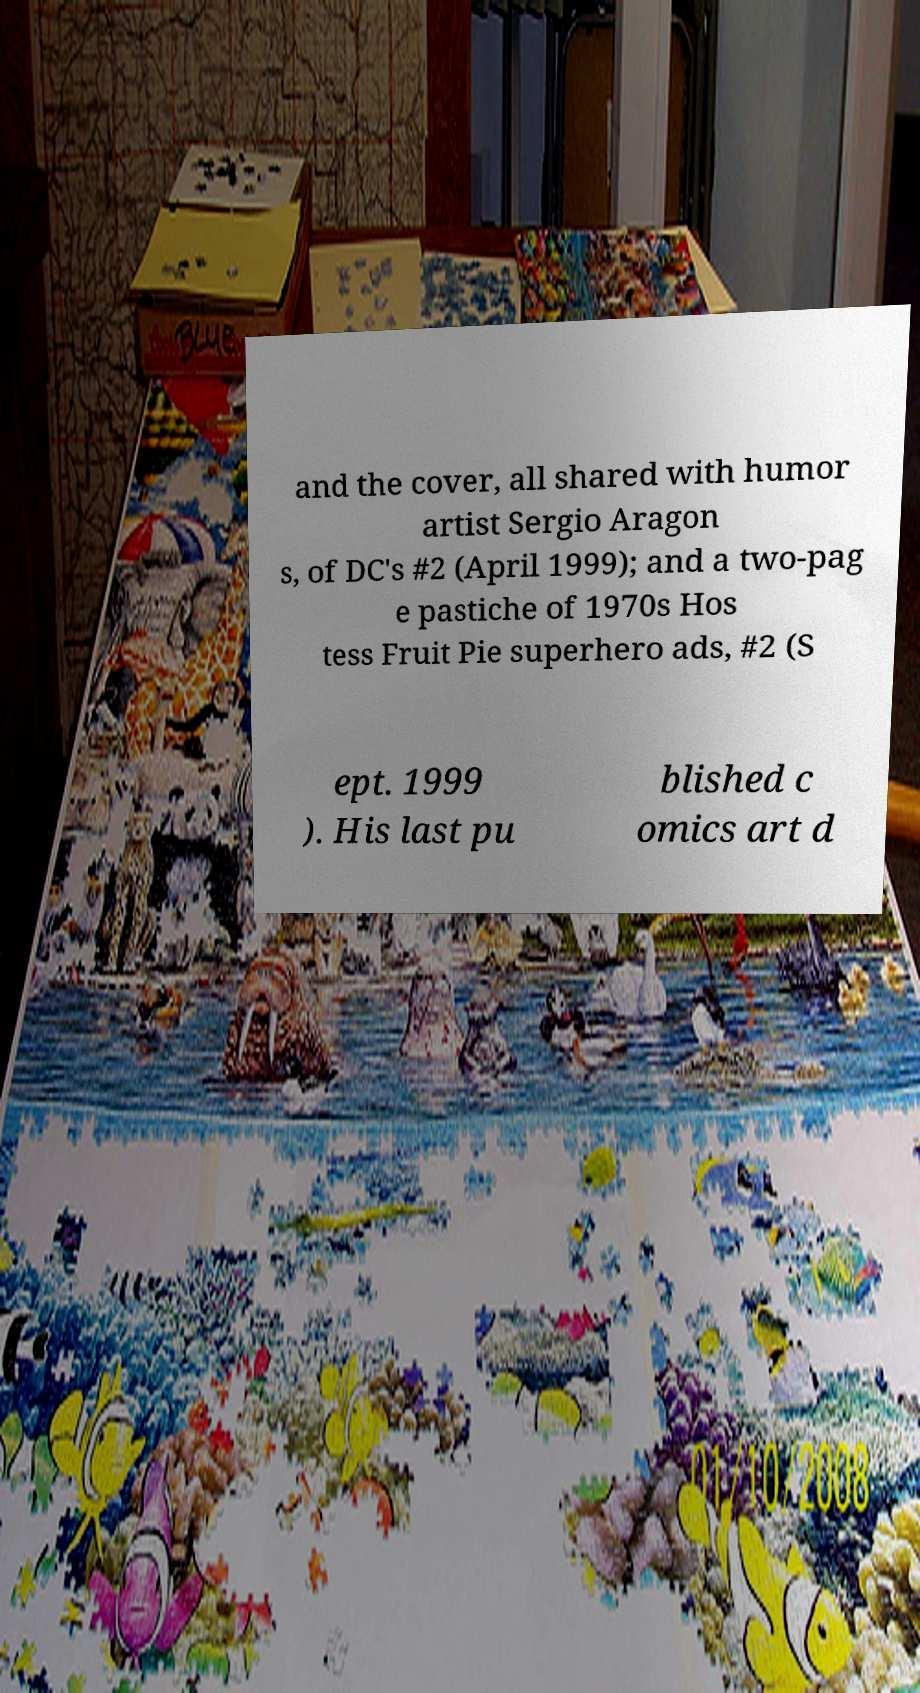What messages or text are displayed in this image? I need them in a readable, typed format. and the cover, all shared with humor artist Sergio Aragon s, of DC's #2 (April 1999); and a two-pag e pastiche of 1970s Hos tess Fruit Pie superhero ads, #2 (S ept. 1999 ). His last pu blished c omics art d 